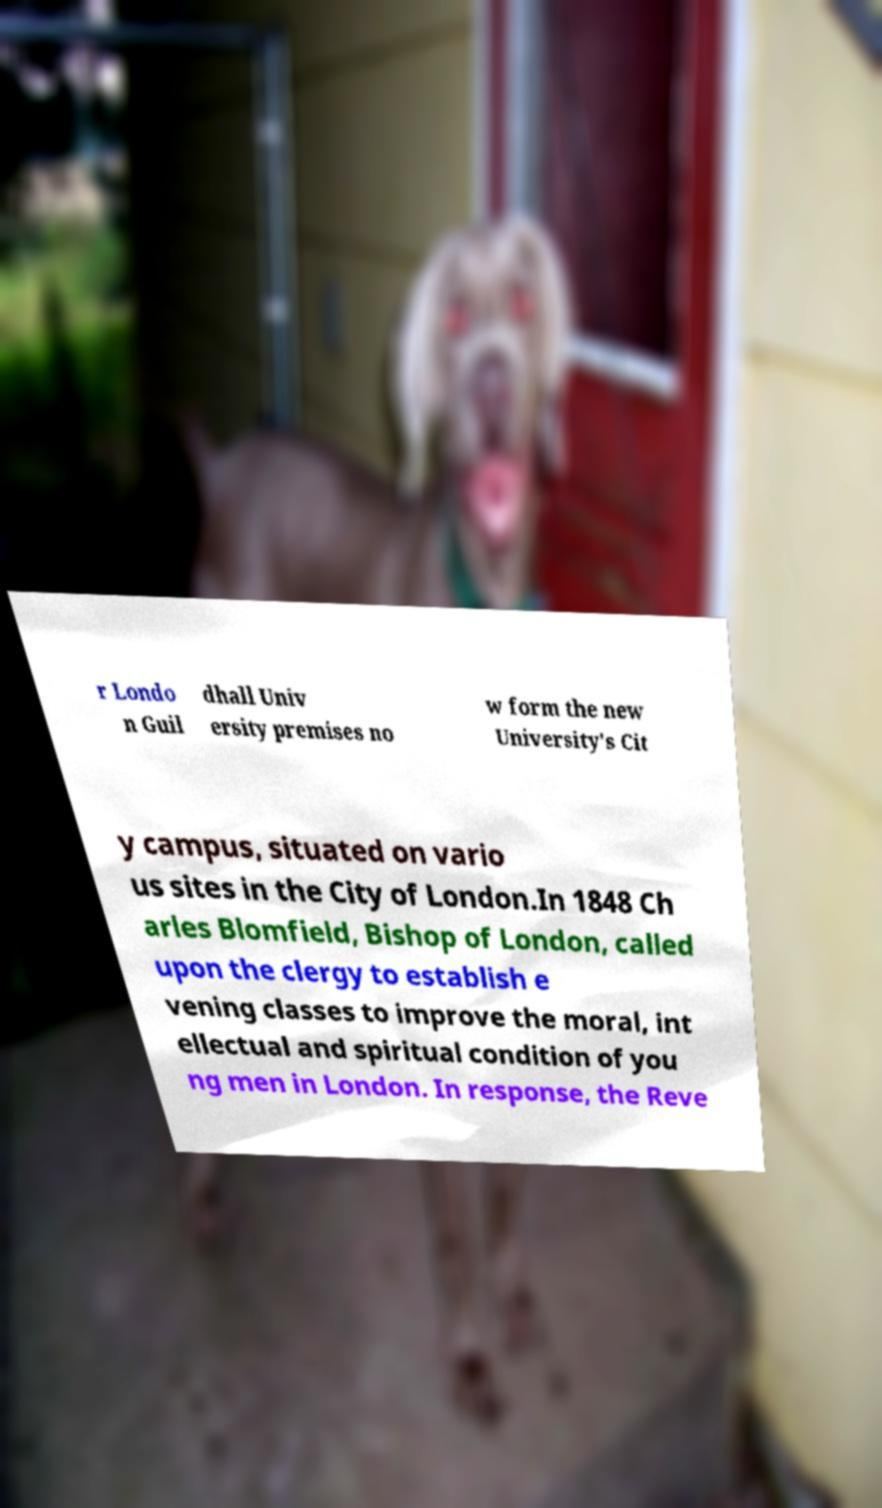For documentation purposes, I need the text within this image transcribed. Could you provide that? r Londo n Guil dhall Univ ersity premises no w form the new University's Cit y campus, situated on vario us sites in the City of London.In 1848 Ch arles Blomfield, Bishop of London, called upon the clergy to establish e vening classes to improve the moral, int ellectual and spiritual condition of you ng men in London. In response, the Reve 